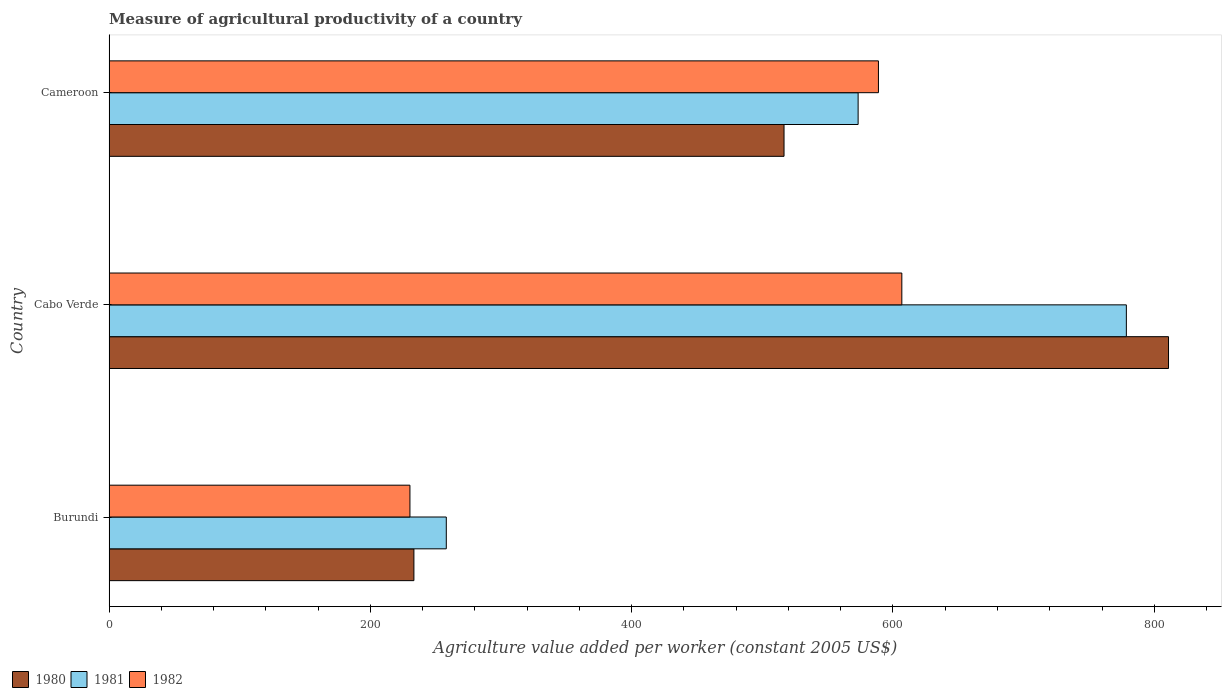How many different coloured bars are there?
Your answer should be compact. 3. Are the number of bars on each tick of the Y-axis equal?
Your response must be concise. Yes. How many bars are there on the 3rd tick from the top?
Offer a terse response. 3. What is the label of the 1st group of bars from the top?
Make the answer very short. Cameroon. In how many cases, is the number of bars for a given country not equal to the number of legend labels?
Provide a short and direct response. 0. What is the measure of agricultural productivity in 1981 in Burundi?
Provide a succinct answer. 258.11. Across all countries, what is the maximum measure of agricultural productivity in 1981?
Your answer should be compact. 778.63. Across all countries, what is the minimum measure of agricultural productivity in 1980?
Your answer should be compact. 233.32. In which country was the measure of agricultural productivity in 1982 maximum?
Make the answer very short. Cabo Verde. In which country was the measure of agricultural productivity in 1981 minimum?
Your response must be concise. Burundi. What is the total measure of agricultural productivity in 1982 in the graph?
Provide a succinct answer. 1425.93. What is the difference between the measure of agricultural productivity in 1982 in Burundi and that in Cameroon?
Provide a succinct answer. -358.59. What is the difference between the measure of agricultural productivity in 1981 in Cameroon and the measure of agricultural productivity in 1982 in Cabo Verde?
Ensure brevity in your answer.  -33.45. What is the average measure of agricultural productivity in 1982 per country?
Make the answer very short. 475.31. What is the difference between the measure of agricultural productivity in 1982 and measure of agricultural productivity in 1980 in Cameroon?
Provide a succinct answer. 72.26. In how many countries, is the measure of agricultural productivity in 1980 greater than 600 US$?
Make the answer very short. 1. What is the ratio of the measure of agricultural productivity in 1981 in Burundi to that in Cameroon?
Provide a succinct answer. 0.45. Is the measure of agricultural productivity in 1980 in Burundi less than that in Cabo Verde?
Offer a terse response. Yes. What is the difference between the highest and the second highest measure of agricultural productivity in 1981?
Ensure brevity in your answer.  205.31. What is the difference between the highest and the lowest measure of agricultural productivity in 1981?
Provide a succinct answer. 520.52. What does the 3rd bar from the top in Burundi represents?
Give a very brief answer. 1980. Is it the case that in every country, the sum of the measure of agricultural productivity in 1981 and measure of agricultural productivity in 1982 is greater than the measure of agricultural productivity in 1980?
Ensure brevity in your answer.  Yes. How many bars are there?
Give a very brief answer. 9. Are all the bars in the graph horizontal?
Your response must be concise. Yes. How many legend labels are there?
Offer a very short reply. 3. How are the legend labels stacked?
Ensure brevity in your answer.  Horizontal. What is the title of the graph?
Make the answer very short. Measure of agricultural productivity of a country. What is the label or title of the X-axis?
Your answer should be very brief. Agriculture value added per worker (constant 2005 US$). What is the Agriculture value added per worker (constant 2005 US$) of 1980 in Burundi?
Ensure brevity in your answer.  233.32. What is the Agriculture value added per worker (constant 2005 US$) of 1981 in Burundi?
Give a very brief answer. 258.11. What is the Agriculture value added per worker (constant 2005 US$) of 1982 in Burundi?
Keep it short and to the point. 230.29. What is the Agriculture value added per worker (constant 2005 US$) in 1980 in Cabo Verde?
Your response must be concise. 810.9. What is the Agriculture value added per worker (constant 2005 US$) of 1981 in Cabo Verde?
Offer a terse response. 778.63. What is the Agriculture value added per worker (constant 2005 US$) in 1982 in Cabo Verde?
Provide a short and direct response. 606.77. What is the Agriculture value added per worker (constant 2005 US$) in 1980 in Cameroon?
Offer a terse response. 516.62. What is the Agriculture value added per worker (constant 2005 US$) in 1981 in Cameroon?
Provide a short and direct response. 573.32. What is the Agriculture value added per worker (constant 2005 US$) in 1982 in Cameroon?
Make the answer very short. 588.87. Across all countries, what is the maximum Agriculture value added per worker (constant 2005 US$) of 1980?
Ensure brevity in your answer.  810.9. Across all countries, what is the maximum Agriculture value added per worker (constant 2005 US$) of 1981?
Make the answer very short. 778.63. Across all countries, what is the maximum Agriculture value added per worker (constant 2005 US$) in 1982?
Give a very brief answer. 606.77. Across all countries, what is the minimum Agriculture value added per worker (constant 2005 US$) of 1980?
Ensure brevity in your answer.  233.32. Across all countries, what is the minimum Agriculture value added per worker (constant 2005 US$) in 1981?
Your answer should be compact. 258.11. Across all countries, what is the minimum Agriculture value added per worker (constant 2005 US$) in 1982?
Make the answer very short. 230.29. What is the total Agriculture value added per worker (constant 2005 US$) of 1980 in the graph?
Your answer should be very brief. 1560.83. What is the total Agriculture value added per worker (constant 2005 US$) in 1981 in the graph?
Ensure brevity in your answer.  1610.06. What is the total Agriculture value added per worker (constant 2005 US$) of 1982 in the graph?
Ensure brevity in your answer.  1425.93. What is the difference between the Agriculture value added per worker (constant 2005 US$) in 1980 in Burundi and that in Cabo Verde?
Offer a very short reply. -577.57. What is the difference between the Agriculture value added per worker (constant 2005 US$) in 1981 in Burundi and that in Cabo Verde?
Ensure brevity in your answer.  -520.52. What is the difference between the Agriculture value added per worker (constant 2005 US$) in 1982 in Burundi and that in Cabo Verde?
Your answer should be compact. -376.49. What is the difference between the Agriculture value added per worker (constant 2005 US$) in 1980 in Burundi and that in Cameroon?
Make the answer very short. -283.29. What is the difference between the Agriculture value added per worker (constant 2005 US$) in 1981 in Burundi and that in Cameroon?
Keep it short and to the point. -315.21. What is the difference between the Agriculture value added per worker (constant 2005 US$) of 1982 in Burundi and that in Cameroon?
Give a very brief answer. -358.59. What is the difference between the Agriculture value added per worker (constant 2005 US$) of 1980 in Cabo Verde and that in Cameroon?
Your answer should be compact. 294.28. What is the difference between the Agriculture value added per worker (constant 2005 US$) in 1981 in Cabo Verde and that in Cameroon?
Offer a very short reply. 205.31. What is the difference between the Agriculture value added per worker (constant 2005 US$) in 1982 in Cabo Verde and that in Cameroon?
Your response must be concise. 17.9. What is the difference between the Agriculture value added per worker (constant 2005 US$) of 1980 in Burundi and the Agriculture value added per worker (constant 2005 US$) of 1981 in Cabo Verde?
Offer a very short reply. -545.31. What is the difference between the Agriculture value added per worker (constant 2005 US$) in 1980 in Burundi and the Agriculture value added per worker (constant 2005 US$) in 1982 in Cabo Verde?
Your answer should be very brief. -373.45. What is the difference between the Agriculture value added per worker (constant 2005 US$) of 1981 in Burundi and the Agriculture value added per worker (constant 2005 US$) of 1982 in Cabo Verde?
Your response must be concise. -348.66. What is the difference between the Agriculture value added per worker (constant 2005 US$) of 1980 in Burundi and the Agriculture value added per worker (constant 2005 US$) of 1981 in Cameroon?
Offer a terse response. -340. What is the difference between the Agriculture value added per worker (constant 2005 US$) in 1980 in Burundi and the Agriculture value added per worker (constant 2005 US$) in 1982 in Cameroon?
Keep it short and to the point. -355.55. What is the difference between the Agriculture value added per worker (constant 2005 US$) of 1981 in Burundi and the Agriculture value added per worker (constant 2005 US$) of 1982 in Cameroon?
Provide a short and direct response. -330.76. What is the difference between the Agriculture value added per worker (constant 2005 US$) of 1980 in Cabo Verde and the Agriculture value added per worker (constant 2005 US$) of 1981 in Cameroon?
Your answer should be compact. 237.58. What is the difference between the Agriculture value added per worker (constant 2005 US$) in 1980 in Cabo Verde and the Agriculture value added per worker (constant 2005 US$) in 1982 in Cameroon?
Give a very brief answer. 222.02. What is the difference between the Agriculture value added per worker (constant 2005 US$) in 1981 in Cabo Verde and the Agriculture value added per worker (constant 2005 US$) in 1982 in Cameroon?
Give a very brief answer. 189.76. What is the average Agriculture value added per worker (constant 2005 US$) of 1980 per country?
Give a very brief answer. 520.28. What is the average Agriculture value added per worker (constant 2005 US$) in 1981 per country?
Your answer should be compact. 536.69. What is the average Agriculture value added per worker (constant 2005 US$) of 1982 per country?
Your answer should be very brief. 475.31. What is the difference between the Agriculture value added per worker (constant 2005 US$) in 1980 and Agriculture value added per worker (constant 2005 US$) in 1981 in Burundi?
Keep it short and to the point. -24.79. What is the difference between the Agriculture value added per worker (constant 2005 US$) in 1980 and Agriculture value added per worker (constant 2005 US$) in 1982 in Burundi?
Give a very brief answer. 3.04. What is the difference between the Agriculture value added per worker (constant 2005 US$) of 1981 and Agriculture value added per worker (constant 2005 US$) of 1982 in Burundi?
Provide a short and direct response. 27.82. What is the difference between the Agriculture value added per worker (constant 2005 US$) in 1980 and Agriculture value added per worker (constant 2005 US$) in 1981 in Cabo Verde?
Keep it short and to the point. 32.27. What is the difference between the Agriculture value added per worker (constant 2005 US$) in 1980 and Agriculture value added per worker (constant 2005 US$) in 1982 in Cabo Verde?
Give a very brief answer. 204.13. What is the difference between the Agriculture value added per worker (constant 2005 US$) of 1981 and Agriculture value added per worker (constant 2005 US$) of 1982 in Cabo Verde?
Your response must be concise. 171.86. What is the difference between the Agriculture value added per worker (constant 2005 US$) in 1980 and Agriculture value added per worker (constant 2005 US$) in 1981 in Cameroon?
Offer a terse response. -56.7. What is the difference between the Agriculture value added per worker (constant 2005 US$) of 1980 and Agriculture value added per worker (constant 2005 US$) of 1982 in Cameroon?
Offer a very short reply. -72.26. What is the difference between the Agriculture value added per worker (constant 2005 US$) in 1981 and Agriculture value added per worker (constant 2005 US$) in 1982 in Cameroon?
Offer a terse response. -15.55. What is the ratio of the Agriculture value added per worker (constant 2005 US$) of 1980 in Burundi to that in Cabo Verde?
Offer a very short reply. 0.29. What is the ratio of the Agriculture value added per worker (constant 2005 US$) of 1981 in Burundi to that in Cabo Verde?
Ensure brevity in your answer.  0.33. What is the ratio of the Agriculture value added per worker (constant 2005 US$) in 1982 in Burundi to that in Cabo Verde?
Your answer should be very brief. 0.38. What is the ratio of the Agriculture value added per worker (constant 2005 US$) in 1980 in Burundi to that in Cameroon?
Provide a succinct answer. 0.45. What is the ratio of the Agriculture value added per worker (constant 2005 US$) of 1981 in Burundi to that in Cameroon?
Your response must be concise. 0.45. What is the ratio of the Agriculture value added per worker (constant 2005 US$) in 1982 in Burundi to that in Cameroon?
Keep it short and to the point. 0.39. What is the ratio of the Agriculture value added per worker (constant 2005 US$) in 1980 in Cabo Verde to that in Cameroon?
Keep it short and to the point. 1.57. What is the ratio of the Agriculture value added per worker (constant 2005 US$) in 1981 in Cabo Verde to that in Cameroon?
Your answer should be compact. 1.36. What is the ratio of the Agriculture value added per worker (constant 2005 US$) of 1982 in Cabo Verde to that in Cameroon?
Make the answer very short. 1.03. What is the difference between the highest and the second highest Agriculture value added per worker (constant 2005 US$) of 1980?
Your answer should be compact. 294.28. What is the difference between the highest and the second highest Agriculture value added per worker (constant 2005 US$) in 1981?
Provide a succinct answer. 205.31. What is the difference between the highest and the second highest Agriculture value added per worker (constant 2005 US$) in 1982?
Your response must be concise. 17.9. What is the difference between the highest and the lowest Agriculture value added per worker (constant 2005 US$) of 1980?
Your answer should be compact. 577.57. What is the difference between the highest and the lowest Agriculture value added per worker (constant 2005 US$) of 1981?
Provide a succinct answer. 520.52. What is the difference between the highest and the lowest Agriculture value added per worker (constant 2005 US$) of 1982?
Keep it short and to the point. 376.49. 